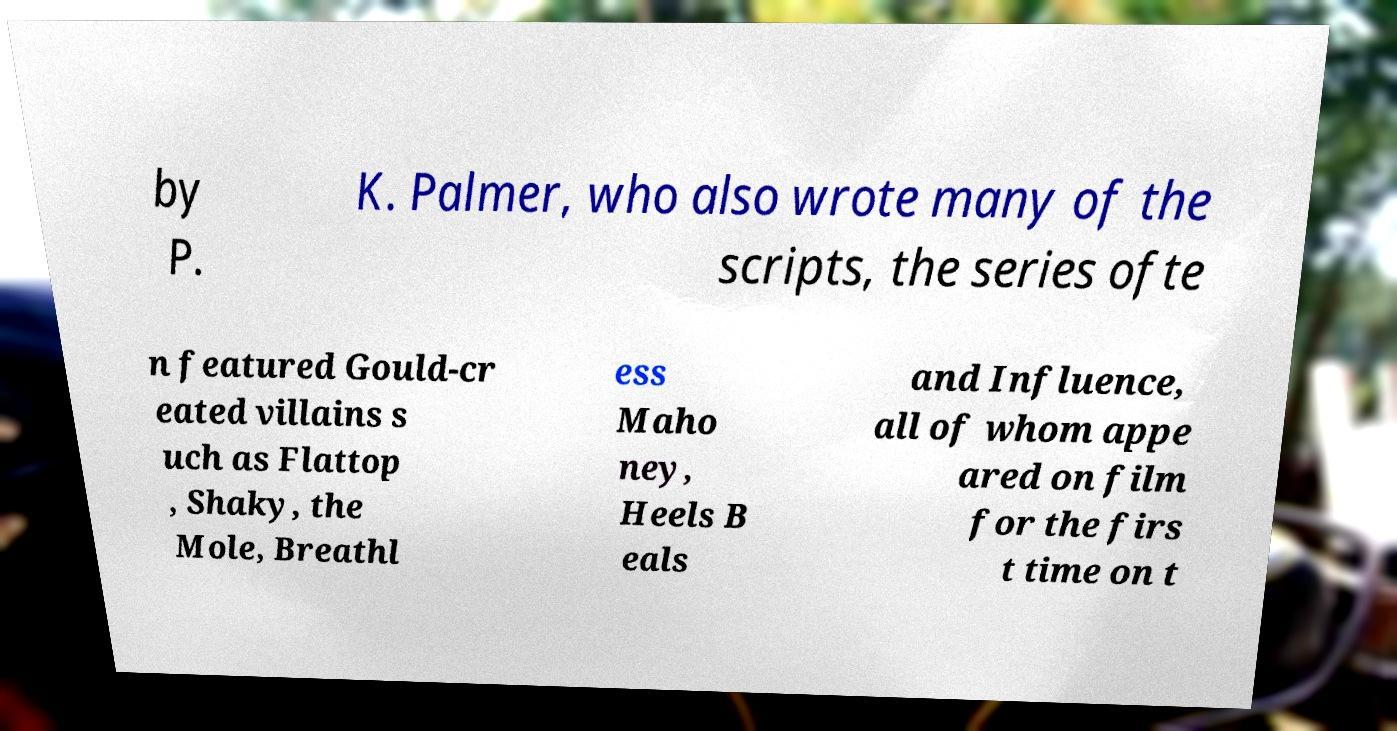What messages or text are displayed in this image? I need them in a readable, typed format. by P. K. Palmer, who also wrote many of the scripts, the series ofte n featured Gould-cr eated villains s uch as Flattop , Shaky, the Mole, Breathl ess Maho ney, Heels B eals and Influence, all of whom appe ared on film for the firs t time on t 